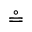Convert formula to latex. <formula><loc_0><loc_0><loc_500><loc_500>\circ e q</formula> 